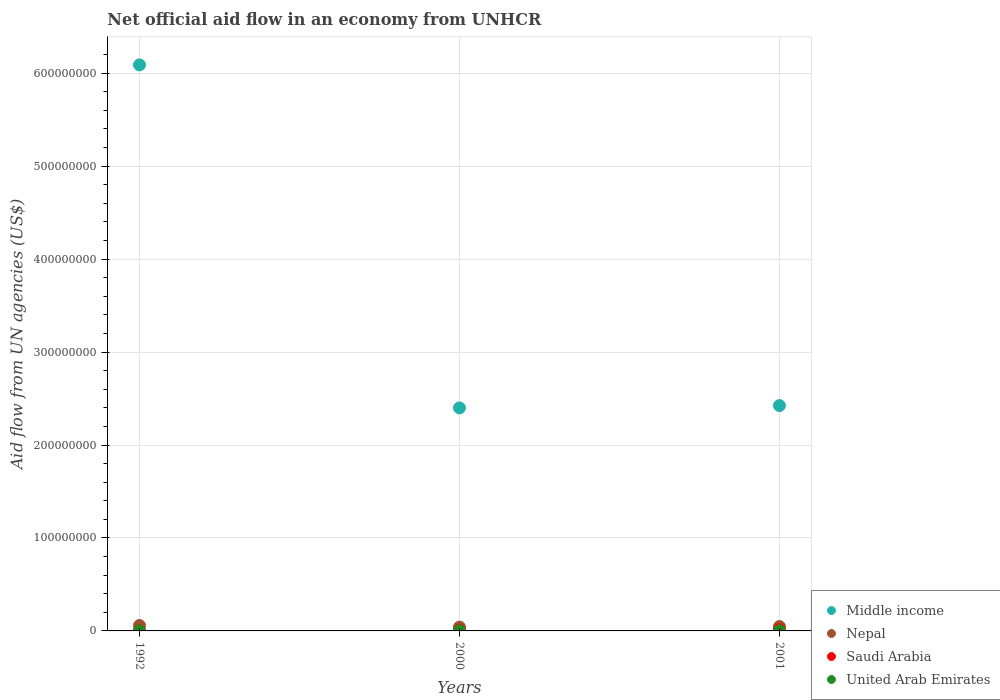How many different coloured dotlines are there?
Give a very brief answer. 4. What is the net official aid flow in Saudi Arabia in 2000?
Offer a terse response. 9.70e+05. Across all years, what is the maximum net official aid flow in Saudi Arabia?
Your answer should be very brief. 1.33e+06. What is the total net official aid flow in Nepal in the graph?
Your response must be concise. 1.47e+07. What is the difference between the net official aid flow in Middle income in 1992 and that in 2001?
Your response must be concise. 3.67e+08. What is the difference between the net official aid flow in United Arab Emirates in 2000 and the net official aid flow in Middle income in 2001?
Your response must be concise. -2.42e+08. In the year 2001, what is the difference between the net official aid flow in United Arab Emirates and net official aid flow in Nepal?
Provide a short and direct response. -4.62e+06. What is the ratio of the net official aid flow in Nepal in 1992 to that in 2001?
Provide a short and direct response. 1.25. Is the net official aid flow in Saudi Arabia in 1992 less than that in 2000?
Your answer should be very brief. Yes. Is the difference between the net official aid flow in United Arab Emirates in 1992 and 2000 greater than the difference between the net official aid flow in Nepal in 1992 and 2000?
Offer a terse response. No. What is the difference between the highest and the second highest net official aid flow in Middle income?
Keep it short and to the point. 3.67e+08. What is the difference between the highest and the lowest net official aid flow in Nepal?
Your answer should be very brief. 1.73e+06. In how many years, is the net official aid flow in Middle income greater than the average net official aid flow in Middle income taken over all years?
Keep it short and to the point. 1. Is it the case that in every year, the sum of the net official aid flow in Middle income and net official aid flow in Saudi Arabia  is greater than the sum of net official aid flow in United Arab Emirates and net official aid flow in Nepal?
Ensure brevity in your answer.  Yes. Is the net official aid flow in United Arab Emirates strictly greater than the net official aid flow in Nepal over the years?
Offer a terse response. No. Is the net official aid flow in Middle income strictly less than the net official aid flow in United Arab Emirates over the years?
Make the answer very short. No. How many dotlines are there?
Offer a terse response. 4. Does the graph contain grids?
Provide a succinct answer. Yes. How are the legend labels stacked?
Offer a very short reply. Vertical. What is the title of the graph?
Provide a succinct answer. Net official aid flow in an economy from UNHCR. What is the label or title of the Y-axis?
Make the answer very short. Aid flow from UN agencies (US$). What is the Aid flow from UN agencies (US$) of Middle income in 1992?
Offer a very short reply. 6.09e+08. What is the Aid flow from UN agencies (US$) in Nepal in 1992?
Offer a terse response. 5.85e+06. What is the Aid flow from UN agencies (US$) of United Arab Emirates in 1992?
Give a very brief answer. 6.00e+04. What is the Aid flow from UN agencies (US$) in Middle income in 2000?
Provide a short and direct response. 2.40e+08. What is the Aid flow from UN agencies (US$) of Nepal in 2000?
Your answer should be compact. 4.12e+06. What is the Aid flow from UN agencies (US$) of Saudi Arabia in 2000?
Make the answer very short. 9.70e+05. What is the Aid flow from UN agencies (US$) in Middle income in 2001?
Offer a very short reply. 2.42e+08. What is the Aid flow from UN agencies (US$) of Nepal in 2001?
Offer a very short reply. 4.69e+06. What is the Aid flow from UN agencies (US$) in Saudi Arabia in 2001?
Provide a short and direct response. 1.33e+06. What is the Aid flow from UN agencies (US$) in United Arab Emirates in 2001?
Offer a very short reply. 7.00e+04. Across all years, what is the maximum Aid flow from UN agencies (US$) of Middle income?
Your answer should be compact. 6.09e+08. Across all years, what is the maximum Aid flow from UN agencies (US$) of Nepal?
Your answer should be very brief. 5.85e+06. Across all years, what is the maximum Aid flow from UN agencies (US$) of Saudi Arabia?
Offer a very short reply. 1.33e+06. Across all years, what is the maximum Aid flow from UN agencies (US$) in United Arab Emirates?
Give a very brief answer. 1.70e+05. Across all years, what is the minimum Aid flow from UN agencies (US$) of Middle income?
Provide a short and direct response. 2.40e+08. Across all years, what is the minimum Aid flow from UN agencies (US$) in Nepal?
Your answer should be very brief. 4.12e+06. Across all years, what is the minimum Aid flow from UN agencies (US$) in United Arab Emirates?
Give a very brief answer. 6.00e+04. What is the total Aid flow from UN agencies (US$) of Middle income in the graph?
Your answer should be compact. 1.09e+09. What is the total Aid flow from UN agencies (US$) of Nepal in the graph?
Provide a short and direct response. 1.47e+07. What is the total Aid flow from UN agencies (US$) in Saudi Arabia in the graph?
Offer a terse response. 2.60e+06. What is the total Aid flow from UN agencies (US$) of United Arab Emirates in the graph?
Ensure brevity in your answer.  3.00e+05. What is the difference between the Aid flow from UN agencies (US$) in Middle income in 1992 and that in 2000?
Provide a succinct answer. 3.69e+08. What is the difference between the Aid flow from UN agencies (US$) in Nepal in 1992 and that in 2000?
Your response must be concise. 1.73e+06. What is the difference between the Aid flow from UN agencies (US$) in Saudi Arabia in 1992 and that in 2000?
Your answer should be compact. -6.70e+05. What is the difference between the Aid flow from UN agencies (US$) of Middle income in 1992 and that in 2001?
Provide a short and direct response. 3.67e+08. What is the difference between the Aid flow from UN agencies (US$) of Nepal in 1992 and that in 2001?
Your response must be concise. 1.16e+06. What is the difference between the Aid flow from UN agencies (US$) in Saudi Arabia in 1992 and that in 2001?
Provide a succinct answer. -1.03e+06. What is the difference between the Aid flow from UN agencies (US$) of Middle income in 2000 and that in 2001?
Provide a succinct answer. -2.49e+06. What is the difference between the Aid flow from UN agencies (US$) in Nepal in 2000 and that in 2001?
Keep it short and to the point. -5.70e+05. What is the difference between the Aid flow from UN agencies (US$) in Saudi Arabia in 2000 and that in 2001?
Offer a very short reply. -3.60e+05. What is the difference between the Aid flow from UN agencies (US$) in United Arab Emirates in 2000 and that in 2001?
Your answer should be very brief. 1.00e+05. What is the difference between the Aid flow from UN agencies (US$) in Middle income in 1992 and the Aid flow from UN agencies (US$) in Nepal in 2000?
Your response must be concise. 6.05e+08. What is the difference between the Aid flow from UN agencies (US$) in Middle income in 1992 and the Aid flow from UN agencies (US$) in Saudi Arabia in 2000?
Ensure brevity in your answer.  6.08e+08. What is the difference between the Aid flow from UN agencies (US$) of Middle income in 1992 and the Aid flow from UN agencies (US$) of United Arab Emirates in 2000?
Provide a succinct answer. 6.09e+08. What is the difference between the Aid flow from UN agencies (US$) of Nepal in 1992 and the Aid flow from UN agencies (US$) of Saudi Arabia in 2000?
Provide a short and direct response. 4.88e+06. What is the difference between the Aid flow from UN agencies (US$) in Nepal in 1992 and the Aid flow from UN agencies (US$) in United Arab Emirates in 2000?
Your answer should be very brief. 5.68e+06. What is the difference between the Aid flow from UN agencies (US$) in Saudi Arabia in 1992 and the Aid flow from UN agencies (US$) in United Arab Emirates in 2000?
Give a very brief answer. 1.30e+05. What is the difference between the Aid flow from UN agencies (US$) in Middle income in 1992 and the Aid flow from UN agencies (US$) in Nepal in 2001?
Offer a terse response. 6.04e+08. What is the difference between the Aid flow from UN agencies (US$) in Middle income in 1992 and the Aid flow from UN agencies (US$) in Saudi Arabia in 2001?
Offer a terse response. 6.08e+08. What is the difference between the Aid flow from UN agencies (US$) in Middle income in 1992 and the Aid flow from UN agencies (US$) in United Arab Emirates in 2001?
Offer a very short reply. 6.09e+08. What is the difference between the Aid flow from UN agencies (US$) in Nepal in 1992 and the Aid flow from UN agencies (US$) in Saudi Arabia in 2001?
Make the answer very short. 4.52e+06. What is the difference between the Aid flow from UN agencies (US$) in Nepal in 1992 and the Aid flow from UN agencies (US$) in United Arab Emirates in 2001?
Offer a very short reply. 5.78e+06. What is the difference between the Aid flow from UN agencies (US$) of Saudi Arabia in 1992 and the Aid flow from UN agencies (US$) of United Arab Emirates in 2001?
Give a very brief answer. 2.30e+05. What is the difference between the Aid flow from UN agencies (US$) in Middle income in 2000 and the Aid flow from UN agencies (US$) in Nepal in 2001?
Provide a short and direct response. 2.35e+08. What is the difference between the Aid flow from UN agencies (US$) in Middle income in 2000 and the Aid flow from UN agencies (US$) in Saudi Arabia in 2001?
Offer a very short reply. 2.39e+08. What is the difference between the Aid flow from UN agencies (US$) of Middle income in 2000 and the Aid flow from UN agencies (US$) of United Arab Emirates in 2001?
Your answer should be compact. 2.40e+08. What is the difference between the Aid flow from UN agencies (US$) of Nepal in 2000 and the Aid flow from UN agencies (US$) of Saudi Arabia in 2001?
Your answer should be very brief. 2.79e+06. What is the difference between the Aid flow from UN agencies (US$) of Nepal in 2000 and the Aid flow from UN agencies (US$) of United Arab Emirates in 2001?
Keep it short and to the point. 4.05e+06. What is the difference between the Aid flow from UN agencies (US$) of Saudi Arabia in 2000 and the Aid flow from UN agencies (US$) of United Arab Emirates in 2001?
Make the answer very short. 9.00e+05. What is the average Aid flow from UN agencies (US$) in Middle income per year?
Your answer should be very brief. 3.64e+08. What is the average Aid flow from UN agencies (US$) in Nepal per year?
Give a very brief answer. 4.89e+06. What is the average Aid flow from UN agencies (US$) of Saudi Arabia per year?
Make the answer very short. 8.67e+05. What is the average Aid flow from UN agencies (US$) of United Arab Emirates per year?
Provide a short and direct response. 1.00e+05. In the year 1992, what is the difference between the Aid flow from UN agencies (US$) of Middle income and Aid flow from UN agencies (US$) of Nepal?
Your answer should be compact. 6.03e+08. In the year 1992, what is the difference between the Aid flow from UN agencies (US$) in Middle income and Aid flow from UN agencies (US$) in Saudi Arabia?
Keep it short and to the point. 6.09e+08. In the year 1992, what is the difference between the Aid flow from UN agencies (US$) of Middle income and Aid flow from UN agencies (US$) of United Arab Emirates?
Offer a terse response. 6.09e+08. In the year 1992, what is the difference between the Aid flow from UN agencies (US$) of Nepal and Aid flow from UN agencies (US$) of Saudi Arabia?
Offer a terse response. 5.55e+06. In the year 1992, what is the difference between the Aid flow from UN agencies (US$) in Nepal and Aid flow from UN agencies (US$) in United Arab Emirates?
Ensure brevity in your answer.  5.79e+06. In the year 2000, what is the difference between the Aid flow from UN agencies (US$) of Middle income and Aid flow from UN agencies (US$) of Nepal?
Your answer should be very brief. 2.36e+08. In the year 2000, what is the difference between the Aid flow from UN agencies (US$) of Middle income and Aid flow from UN agencies (US$) of Saudi Arabia?
Your answer should be compact. 2.39e+08. In the year 2000, what is the difference between the Aid flow from UN agencies (US$) of Middle income and Aid flow from UN agencies (US$) of United Arab Emirates?
Provide a short and direct response. 2.40e+08. In the year 2000, what is the difference between the Aid flow from UN agencies (US$) of Nepal and Aid flow from UN agencies (US$) of Saudi Arabia?
Your answer should be very brief. 3.15e+06. In the year 2000, what is the difference between the Aid flow from UN agencies (US$) of Nepal and Aid flow from UN agencies (US$) of United Arab Emirates?
Give a very brief answer. 3.95e+06. In the year 2001, what is the difference between the Aid flow from UN agencies (US$) of Middle income and Aid flow from UN agencies (US$) of Nepal?
Ensure brevity in your answer.  2.38e+08. In the year 2001, what is the difference between the Aid flow from UN agencies (US$) in Middle income and Aid flow from UN agencies (US$) in Saudi Arabia?
Ensure brevity in your answer.  2.41e+08. In the year 2001, what is the difference between the Aid flow from UN agencies (US$) of Middle income and Aid flow from UN agencies (US$) of United Arab Emirates?
Give a very brief answer. 2.42e+08. In the year 2001, what is the difference between the Aid flow from UN agencies (US$) in Nepal and Aid flow from UN agencies (US$) in Saudi Arabia?
Offer a terse response. 3.36e+06. In the year 2001, what is the difference between the Aid flow from UN agencies (US$) of Nepal and Aid flow from UN agencies (US$) of United Arab Emirates?
Make the answer very short. 4.62e+06. In the year 2001, what is the difference between the Aid flow from UN agencies (US$) in Saudi Arabia and Aid flow from UN agencies (US$) in United Arab Emirates?
Offer a terse response. 1.26e+06. What is the ratio of the Aid flow from UN agencies (US$) in Middle income in 1992 to that in 2000?
Your response must be concise. 2.54. What is the ratio of the Aid flow from UN agencies (US$) of Nepal in 1992 to that in 2000?
Ensure brevity in your answer.  1.42. What is the ratio of the Aid flow from UN agencies (US$) in Saudi Arabia in 1992 to that in 2000?
Provide a succinct answer. 0.31. What is the ratio of the Aid flow from UN agencies (US$) in United Arab Emirates in 1992 to that in 2000?
Make the answer very short. 0.35. What is the ratio of the Aid flow from UN agencies (US$) in Middle income in 1992 to that in 2001?
Provide a short and direct response. 2.51. What is the ratio of the Aid flow from UN agencies (US$) in Nepal in 1992 to that in 2001?
Give a very brief answer. 1.25. What is the ratio of the Aid flow from UN agencies (US$) in Saudi Arabia in 1992 to that in 2001?
Your answer should be very brief. 0.23. What is the ratio of the Aid flow from UN agencies (US$) in United Arab Emirates in 1992 to that in 2001?
Keep it short and to the point. 0.86. What is the ratio of the Aid flow from UN agencies (US$) in Nepal in 2000 to that in 2001?
Keep it short and to the point. 0.88. What is the ratio of the Aid flow from UN agencies (US$) in Saudi Arabia in 2000 to that in 2001?
Your response must be concise. 0.73. What is the ratio of the Aid flow from UN agencies (US$) of United Arab Emirates in 2000 to that in 2001?
Your answer should be compact. 2.43. What is the difference between the highest and the second highest Aid flow from UN agencies (US$) in Middle income?
Provide a short and direct response. 3.67e+08. What is the difference between the highest and the second highest Aid flow from UN agencies (US$) of Nepal?
Make the answer very short. 1.16e+06. What is the difference between the highest and the second highest Aid flow from UN agencies (US$) in Saudi Arabia?
Keep it short and to the point. 3.60e+05. What is the difference between the highest and the second highest Aid flow from UN agencies (US$) in United Arab Emirates?
Ensure brevity in your answer.  1.00e+05. What is the difference between the highest and the lowest Aid flow from UN agencies (US$) in Middle income?
Provide a succinct answer. 3.69e+08. What is the difference between the highest and the lowest Aid flow from UN agencies (US$) in Nepal?
Ensure brevity in your answer.  1.73e+06. What is the difference between the highest and the lowest Aid flow from UN agencies (US$) in Saudi Arabia?
Ensure brevity in your answer.  1.03e+06. What is the difference between the highest and the lowest Aid flow from UN agencies (US$) of United Arab Emirates?
Your answer should be compact. 1.10e+05. 